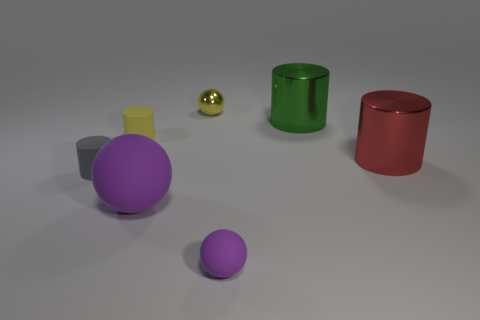The sphere that is the same size as the yellow shiny thing is what color?
Your answer should be compact. Purple. Are there any gray matte objects that have the same shape as the green metallic object?
Provide a succinct answer. Yes. There is a large object that is in front of the large red shiny thing in front of the small yellow object that is to the right of the tiny yellow rubber thing; what is its material?
Your answer should be compact. Rubber. How many other objects are the same size as the yellow metallic ball?
Keep it short and to the point. 3. The small metallic sphere is what color?
Give a very brief answer. Yellow. What number of metal objects are either big green things or red blocks?
Your answer should be compact. 1. Is there anything else that is the same material as the large purple sphere?
Your answer should be compact. Yes. How big is the sphere behind the large object that is to the left of the ball that is behind the big green thing?
Your answer should be compact. Small. What size is the metal object that is both on the left side of the big red metallic cylinder and on the right side of the small matte sphere?
Provide a succinct answer. Large. There is a big cylinder behind the yellow rubber cylinder; is it the same color as the tiny matte object that is behind the gray object?
Provide a succinct answer. No. 